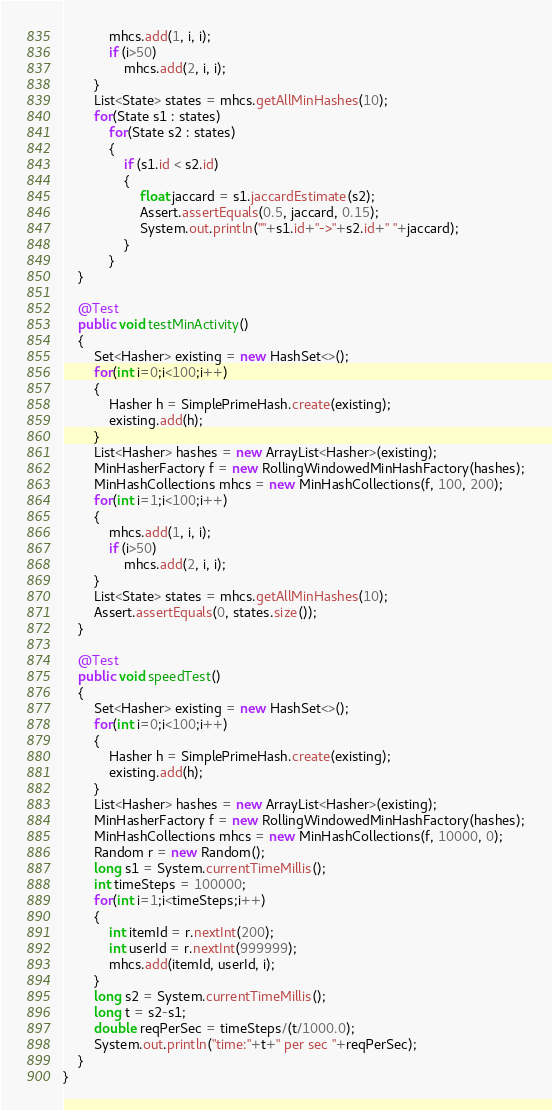Convert code to text. <code><loc_0><loc_0><loc_500><loc_500><_Java_>			mhcs.add(1, i, i);
			if (i>50)
				mhcs.add(2, i, i);
		}
		List<State> states = mhcs.getAllMinHashes(10);
		for(State s1 : states)
			for(State s2 : states)
			{
				if (s1.id < s2.id)
				{
					float jaccard = s1.jaccardEstimate(s2);
					Assert.assertEquals(0.5, jaccard, 0.15);
					System.out.println(""+s1.id+"->"+s2.id+" "+jaccard);
				}
			}
	}
	
	@Test
	public void testMinActivity()
	{
		Set<Hasher> existing = new HashSet<>();
		for(int i=0;i<100;i++)
		{
			Hasher h = SimplePrimeHash.create(existing);
			existing.add(h);
		}
		List<Hasher> hashes = new ArrayList<Hasher>(existing);
		MinHasherFactory f = new RollingWindowedMinHashFactory(hashes);
		MinHashCollections mhcs = new MinHashCollections(f, 100, 200);
		for(int i=1;i<100;i++)
		{
			mhcs.add(1, i, i);
			if (i>50)
				mhcs.add(2, i, i);
		}
		List<State> states = mhcs.getAllMinHashes(10);
		Assert.assertEquals(0, states.size());
	}
	
	@Test
	public void speedTest()
	{
		Set<Hasher> existing = new HashSet<>();
		for(int i=0;i<100;i++)
		{
			Hasher h = SimplePrimeHash.create(existing);
			existing.add(h);
		}
		List<Hasher> hashes = new ArrayList<Hasher>(existing);
		MinHasherFactory f = new RollingWindowedMinHashFactory(hashes);
		MinHashCollections mhcs = new MinHashCollections(f, 10000, 0);
		Random r = new Random();
		long s1 = System.currentTimeMillis();
		int timeSteps = 100000;
		for(int i=1;i<timeSteps;i++)
		{
			int itemId = r.nextInt(200);
			int userId = r.nextInt(999999);
			mhcs.add(itemId, userId, i);
		}
		long s2 = System.currentTimeMillis();
		long t = s2-s1;
		double reqPerSec = timeSteps/(t/1000.0);
		System.out.println("time:"+t+" per sec "+reqPerSec);
	}
}
</code> 